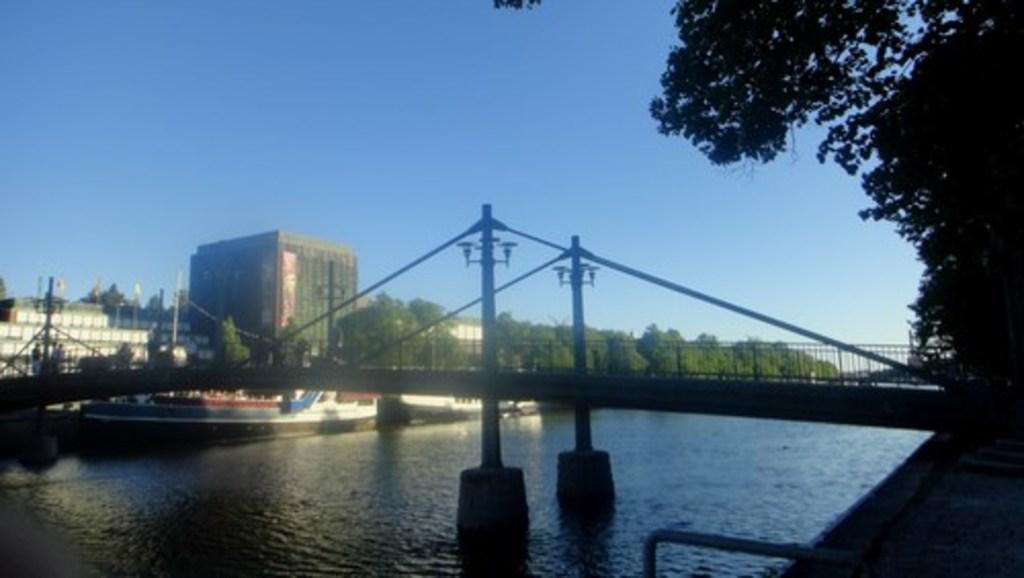What is in the water in the image? There are boats in the water. What else can be seen in the water besides the boats? There are poles in the water. What structures are visible in the image? There are buildings and a fence in the image. What type of vegetation is present in the image? There are trees in the image. Who or what can be seen in the image? There are people in the image. What is visible in the background of the image? The sky is visible in the background of the image. Where is the hen located in the image? There is no hen present in the image. What role does the grandfather play in the image? There is no grandfather present in the image. 